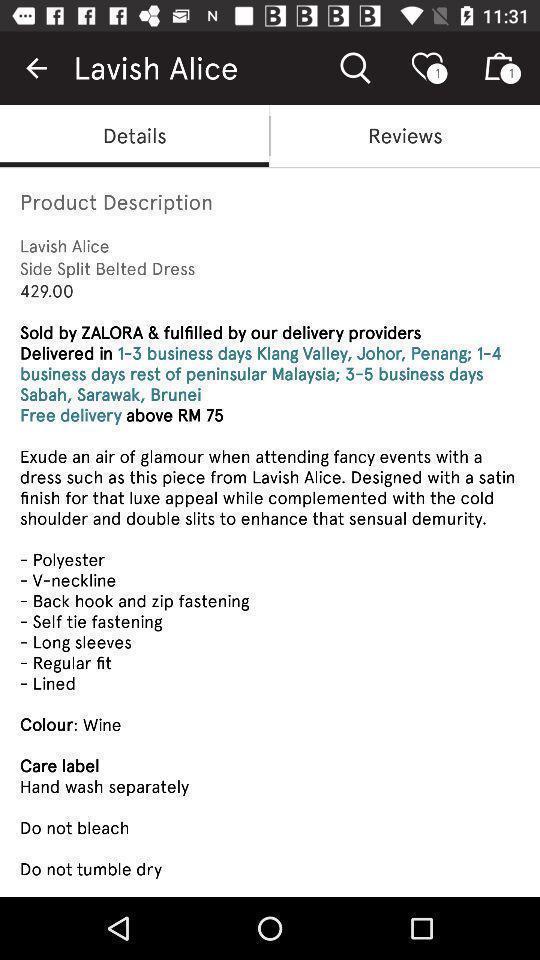What is the overall content of this screenshot? Screen shows details on fashion destination app. 